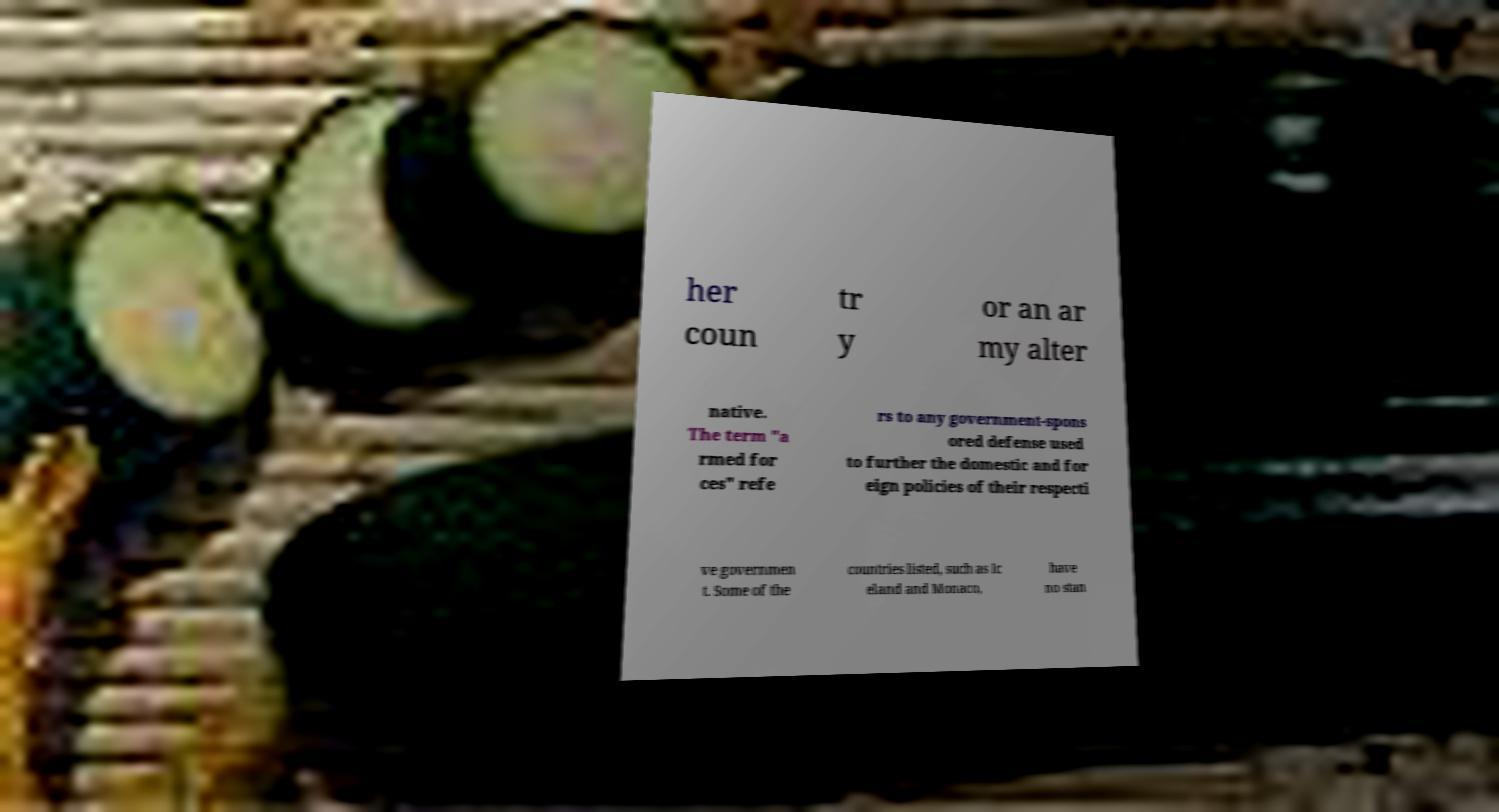There's text embedded in this image that I need extracted. Can you transcribe it verbatim? her coun tr y or an ar my alter native. The term "a rmed for ces" refe rs to any government-spons ored defense used to further the domestic and for eign policies of their respecti ve governmen t. Some of the countries listed, such as Ic eland and Monaco, have no stan 